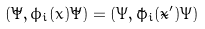Convert formula to latex. <formula><loc_0><loc_0><loc_500><loc_500>( \tilde { \Psi } , \bar { \phi } _ { i } ( \bar { x } ) \tilde { \Psi } ) = ( \bar { \Psi } , \tilde { \phi } _ { i } ( \tilde { x } ^ { \prime } ) \bar { \Psi } )</formula> 